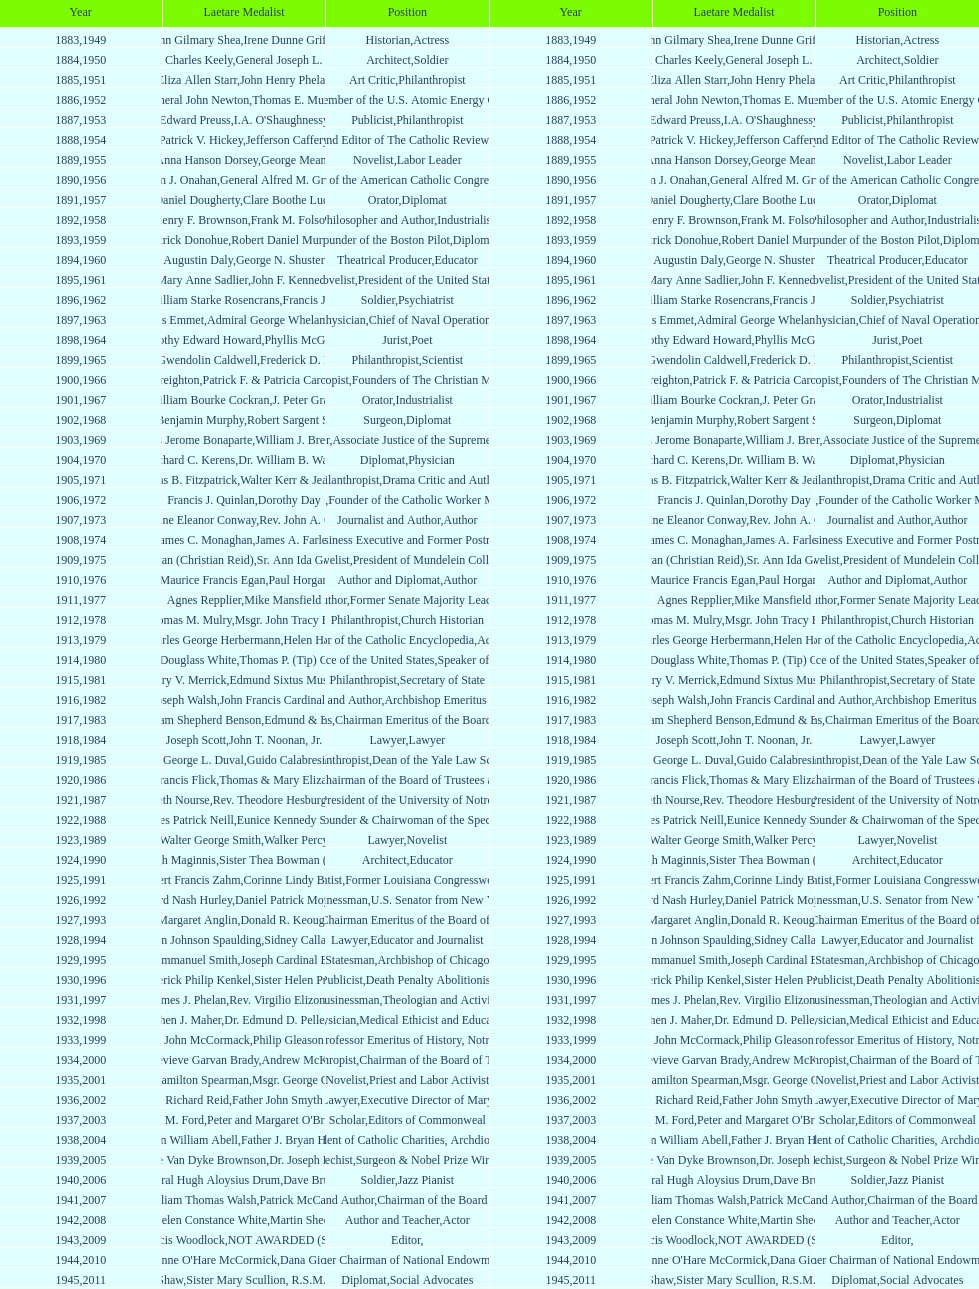What is the count of laetare medalists who served as diplomats? 8. 